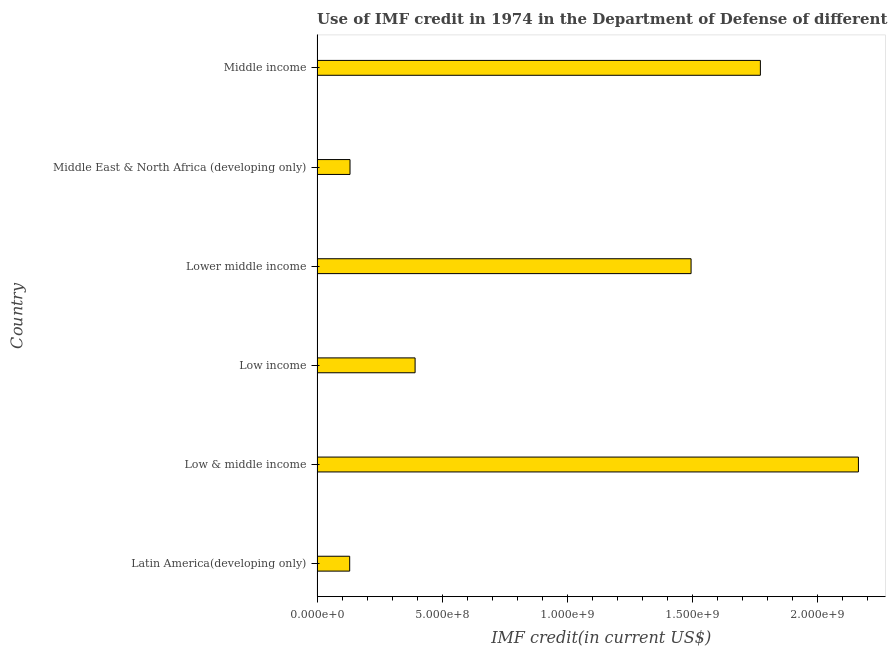Does the graph contain any zero values?
Your answer should be very brief. No. What is the title of the graph?
Provide a short and direct response. Use of IMF credit in 1974 in the Department of Defense of different countries. What is the label or title of the X-axis?
Give a very brief answer. IMF credit(in current US$). What is the use of imf credit in dod in Latin America(developing only)?
Give a very brief answer. 1.30e+08. Across all countries, what is the maximum use of imf credit in dod?
Provide a short and direct response. 2.16e+09. Across all countries, what is the minimum use of imf credit in dod?
Your answer should be very brief. 1.30e+08. In which country was the use of imf credit in dod minimum?
Offer a terse response. Latin America(developing only). What is the sum of the use of imf credit in dod?
Offer a terse response. 6.09e+09. What is the difference between the use of imf credit in dod in Latin America(developing only) and Middle income?
Your answer should be very brief. -1.64e+09. What is the average use of imf credit in dod per country?
Your answer should be compact. 1.01e+09. What is the median use of imf credit in dod?
Ensure brevity in your answer.  9.44e+08. In how many countries, is the use of imf credit in dod greater than 1400000000 US$?
Your response must be concise. 3. What is the ratio of the use of imf credit in dod in Lower middle income to that in Middle income?
Your answer should be compact. 0.84. What is the difference between the highest and the second highest use of imf credit in dod?
Keep it short and to the point. 3.92e+08. What is the difference between the highest and the lowest use of imf credit in dod?
Your answer should be very brief. 2.03e+09. In how many countries, is the use of imf credit in dod greater than the average use of imf credit in dod taken over all countries?
Ensure brevity in your answer.  3. How many bars are there?
Provide a short and direct response. 6. Are the values on the major ticks of X-axis written in scientific E-notation?
Your answer should be compact. Yes. What is the IMF credit(in current US$) of Latin America(developing only)?
Provide a succinct answer. 1.30e+08. What is the IMF credit(in current US$) of Low & middle income?
Ensure brevity in your answer.  2.16e+09. What is the IMF credit(in current US$) of Low income?
Offer a very short reply. 3.92e+08. What is the IMF credit(in current US$) in Lower middle income?
Keep it short and to the point. 1.50e+09. What is the IMF credit(in current US$) in Middle East & North Africa (developing only)?
Offer a terse response. 1.32e+08. What is the IMF credit(in current US$) in Middle income?
Keep it short and to the point. 1.77e+09. What is the difference between the IMF credit(in current US$) in Latin America(developing only) and Low & middle income?
Your response must be concise. -2.03e+09. What is the difference between the IMF credit(in current US$) in Latin America(developing only) and Low income?
Provide a short and direct response. -2.62e+08. What is the difference between the IMF credit(in current US$) in Latin America(developing only) and Lower middle income?
Keep it short and to the point. -1.37e+09. What is the difference between the IMF credit(in current US$) in Latin America(developing only) and Middle East & North Africa (developing only)?
Your response must be concise. -1.32e+06. What is the difference between the IMF credit(in current US$) in Latin America(developing only) and Middle income?
Your response must be concise. -1.64e+09. What is the difference between the IMF credit(in current US$) in Low & middle income and Low income?
Give a very brief answer. 1.77e+09. What is the difference between the IMF credit(in current US$) in Low & middle income and Lower middle income?
Offer a very short reply. 6.69e+08. What is the difference between the IMF credit(in current US$) in Low & middle income and Middle East & North Africa (developing only)?
Offer a very short reply. 2.03e+09. What is the difference between the IMF credit(in current US$) in Low & middle income and Middle income?
Keep it short and to the point. 3.92e+08. What is the difference between the IMF credit(in current US$) in Low income and Lower middle income?
Offer a terse response. -1.10e+09. What is the difference between the IMF credit(in current US$) in Low income and Middle East & North Africa (developing only)?
Offer a very short reply. 2.60e+08. What is the difference between the IMF credit(in current US$) in Low income and Middle income?
Provide a succinct answer. -1.38e+09. What is the difference between the IMF credit(in current US$) in Lower middle income and Middle East & North Africa (developing only)?
Your response must be concise. 1.36e+09. What is the difference between the IMF credit(in current US$) in Lower middle income and Middle income?
Your answer should be compact. -2.77e+08. What is the difference between the IMF credit(in current US$) in Middle East & North Africa (developing only) and Middle income?
Provide a short and direct response. -1.64e+09. What is the ratio of the IMF credit(in current US$) in Latin America(developing only) to that in Low income?
Your answer should be very brief. 0.33. What is the ratio of the IMF credit(in current US$) in Latin America(developing only) to that in Lower middle income?
Provide a short and direct response. 0.09. What is the ratio of the IMF credit(in current US$) in Latin America(developing only) to that in Middle income?
Give a very brief answer. 0.07. What is the ratio of the IMF credit(in current US$) in Low & middle income to that in Low income?
Offer a very short reply. 5.52. What is the ratio of the IMF credit(in current US$) in Low & middle income to that in Lower middle income?
Ensure brevity in your answer.  1.45. What is the ratio of the IMF credit(in current US$) in Low & middle income to that in Middle East & North Africa (developing only)?
Provide a short and direct response. 16.43. What is the ratio of the IMF credit(in current US$) in Low & middle income to that in Middle income?
Your answer should be compact. 1.22. What is the ratio of the IMF credit(in current US$) in Low income to that in Lower middle income?
Your answer should be compact. 0.26. What is the ratio of the IMF credit(in current US$) in Low income to that in Middle East & North Africa (developing only)?
Offer a terse response. 2.98. What is the ratio of the IMF credit(in current US$) in Low income to that in Middle income?
Offer a very short reply. 0.22. What is the ratio of the IMF credit(in current US$) in Lower middle income to that in Middle East & North Africa (developing only)?
Your response must be concise. 11.35. What is the ratio of the IMF credit(in current US$) in Lower middle income to that in Middle income?
Keep it short and to the point. 0.84. What is the ratio of the IMF credit(in current US$) in Middle East & North Africa (developing only) to that in Middle income?
Provide a short and direct response. 0.07. 